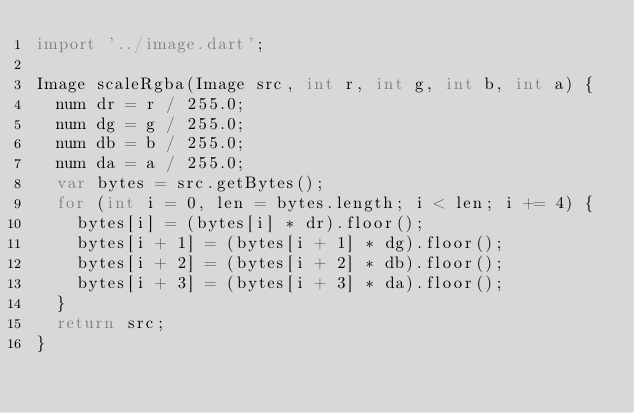Convert code to text. <code><loc_0><loc_0><loc_500><loc_500><_Dart_>import '../image.dart';

Image scaleRgba(Image src, int r, int g, int b, int a) {
  num dr = r / 255.0;
  num dg = g / 255.0;
  num db = b / 255.0;
  num da = a / 255.0;
  var bytes = src.getBytes();
  for (int i = 0, len = bytes.length; i < len; i += 4) {
    bytes[i] = (bytes[i] * dr).floor();
    bytes[i + 1] = (bytes[i + 1] * dg).floor();
    bytes[i + 2] = (bytes[i + 2] * db).floor();
    bytes[i + 3] = (bytes[i + 3] * da).floor();
  }
  return src;
}
</code> 